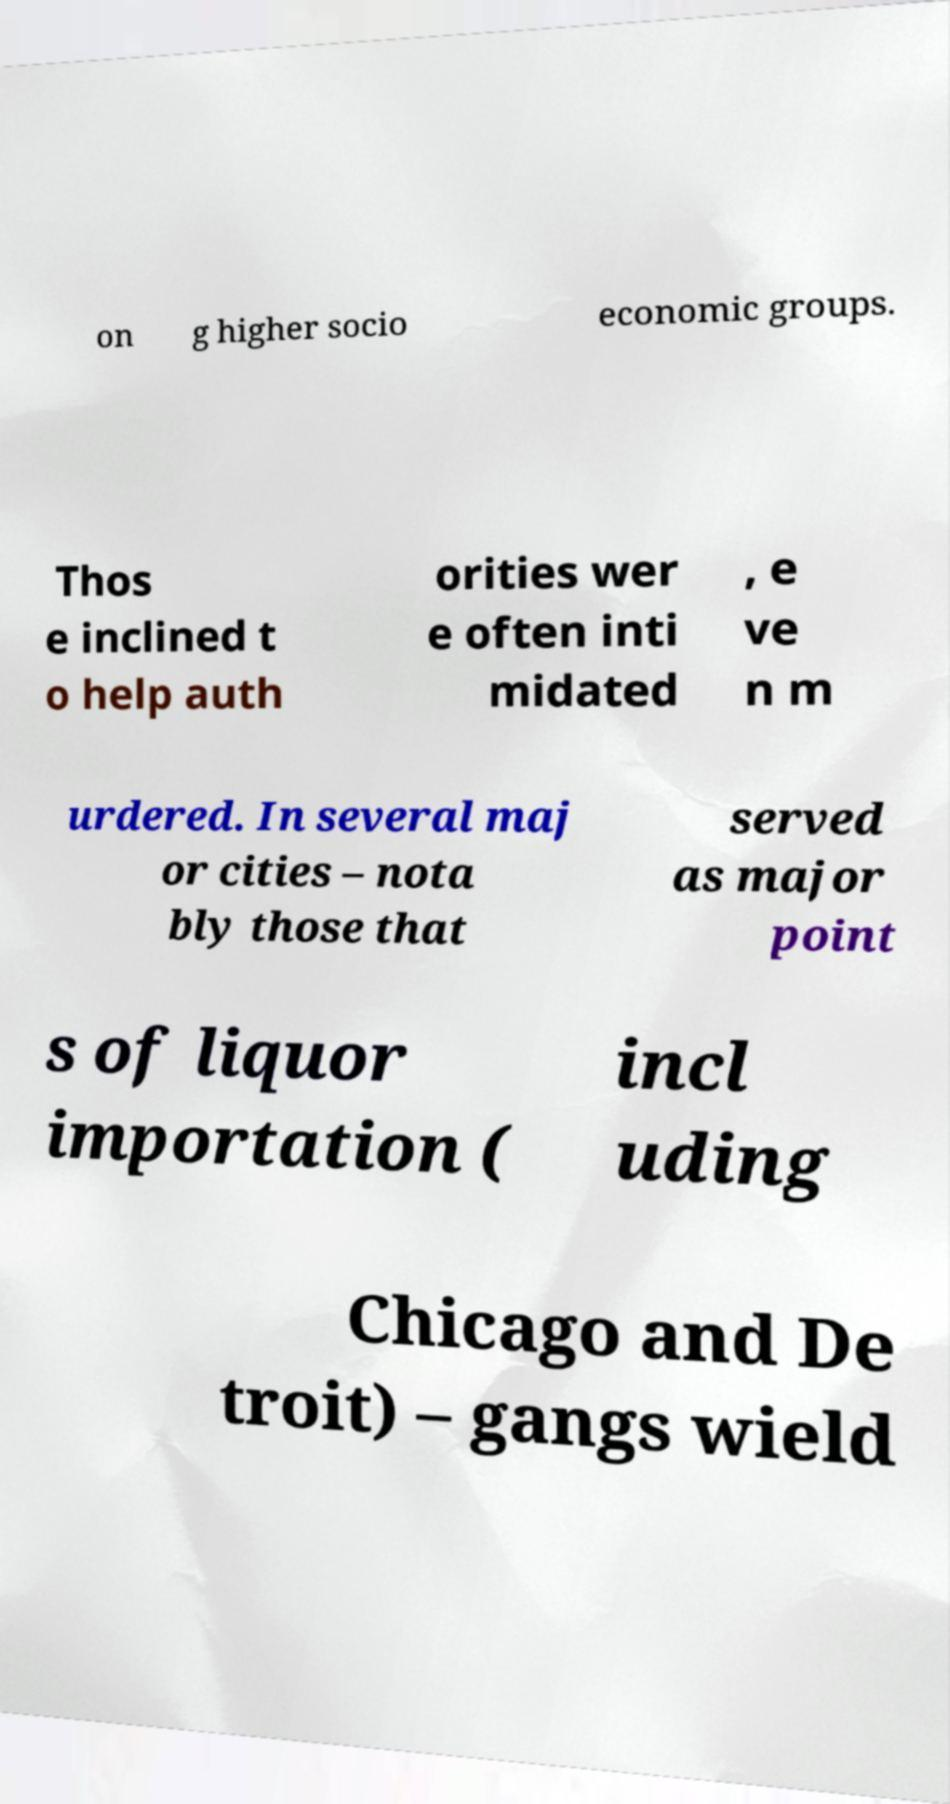I need the written content from this picture converted into text. Can you do that? on g higher socio economic groups. Thos e inclined t o help auth orities wer e often inti midated , e ve n m urdered. In several maj or cities – nota bly those that served as major point s of liquor importation ( incl uding Chicago and De troit) – gangs wield 